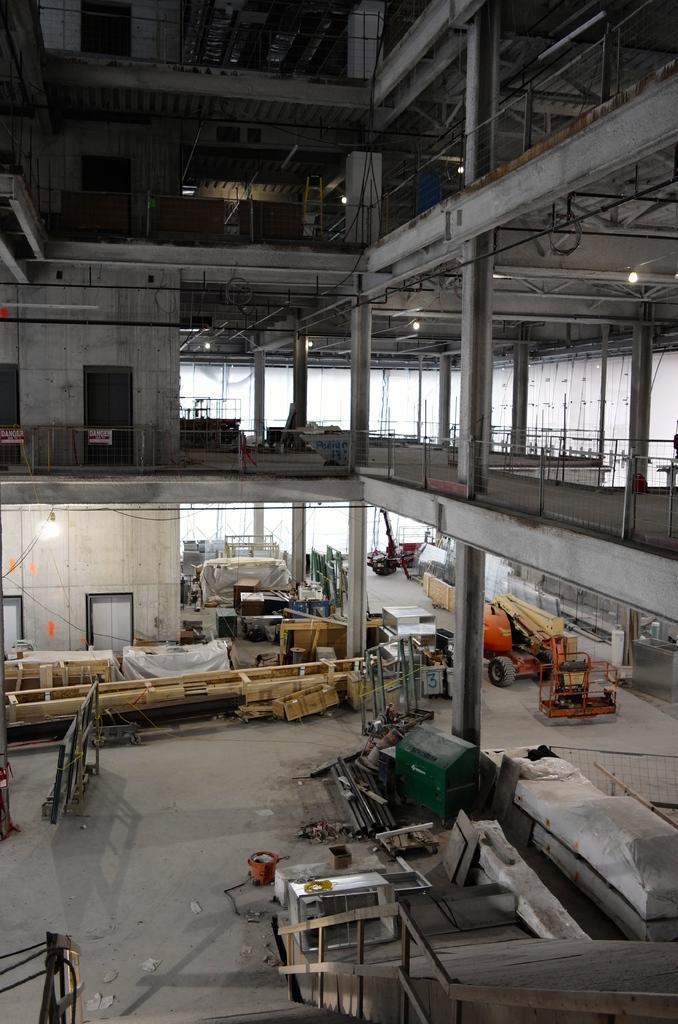Please provide a concise description of this image. This image is clicked from a top view. There are machines, wooden planks, vehicles and many objects on the floor. To the left there are doors to the wall. At the bottom there is a staircase. To the right there is a railing. There are lights to the ceiling. 